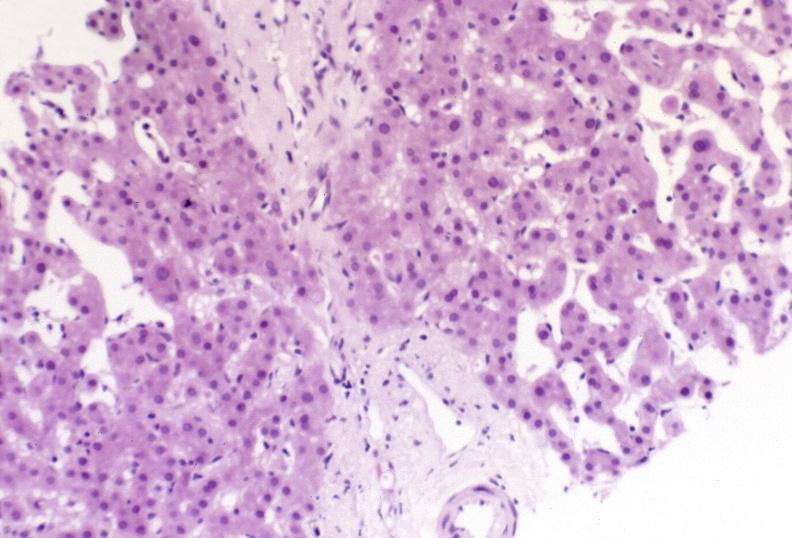what is present?
Answer the question using a single word or phrase. Liver 